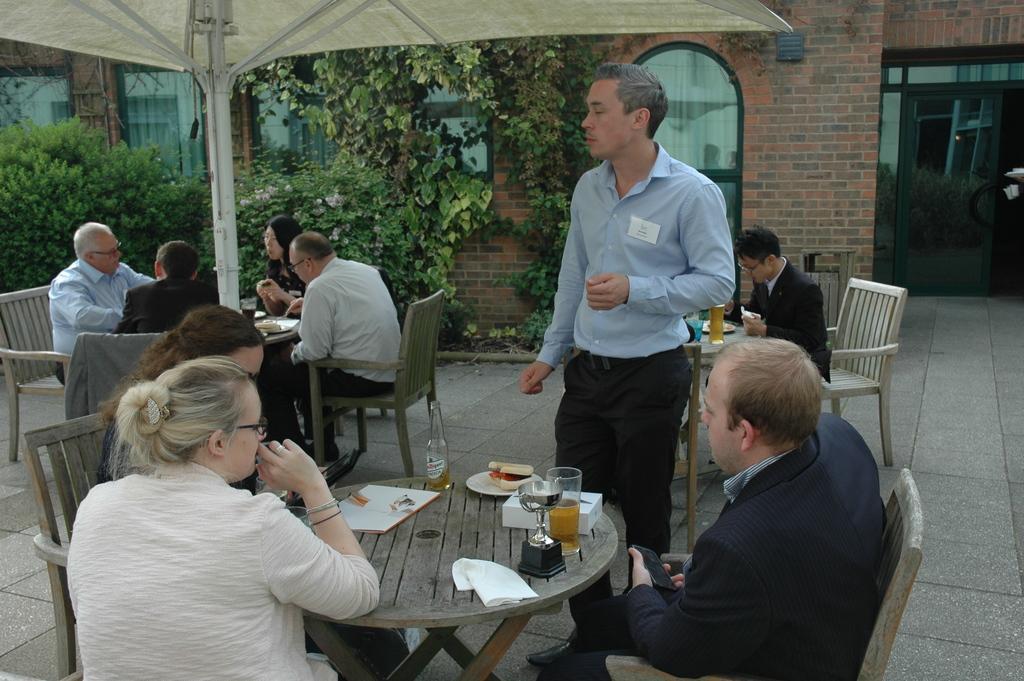Describe this image in one or two sentences. This Image is clicked outside the room, there are bushes on the top left corner and there is a door on the top right corner, there are so many tables and chairs around those tables in this image there are so many people sitting on the chairs. The person who is standing wore blue shirt and black pant. The person beside him is wearing black blazer. On the table there is a book, bottle ,plate, glass ,Shield and box. 